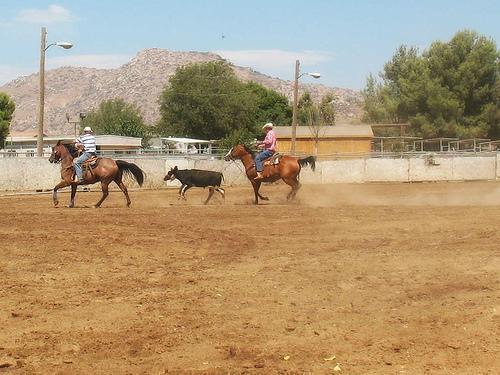How many mammals are in this scene?
Give a very brief answer. 5. How many people are wearing striped shirts?
Give a very brief answer. 1. How many horses are visible?
Give a very brief answer. 2. How many blue umbrellas are on the beach?
Give a very brief answer. 0. 